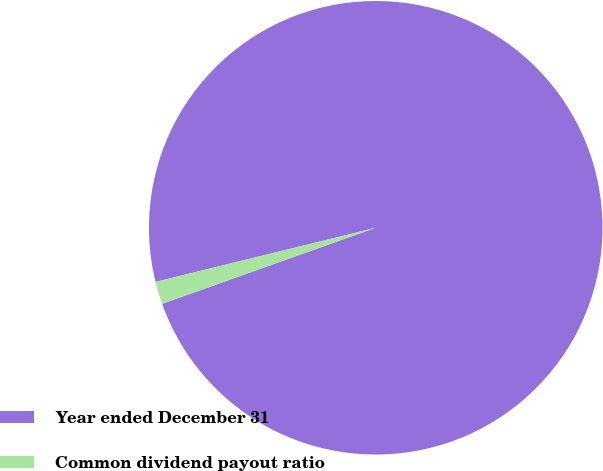Convert chart to OTSL. <chart><loc_0><loc_0><loc_500><loc_500><pie_chart><fcel>Year ended December 31<fcel>Common dividend payout ratio<nl><fcel>98.39%<fcel>1.61%<nl></chart> 